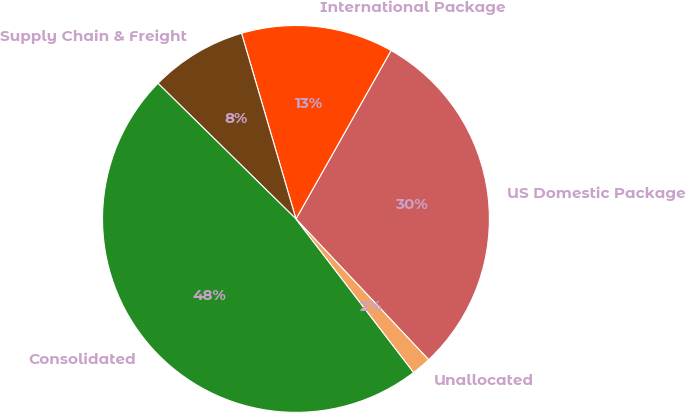Convert chart to OTSL. <chart><loc_0><loc_0><loc_500><loc_500><pie_chart><fcel>US Domestic Package<fcel>International Package<fcel>Supply Chain & Freight<fcel>Consolidated<fcel>Unallocated<nl><fcel>29.79%<fcel>12.72%<fcel>8.1%<fcel>47.77%<fcel>1.62%<nl></chart> 